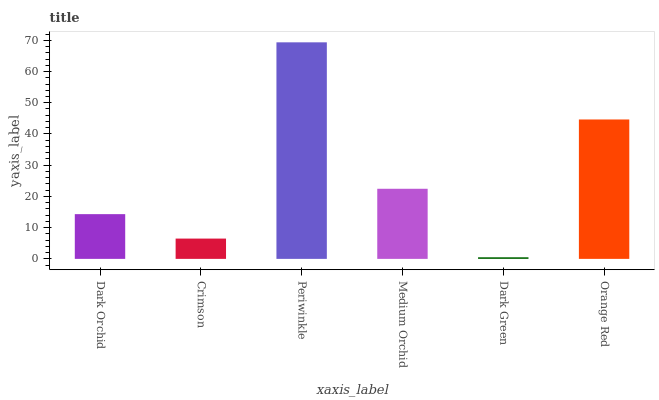Is Dark Green the minimum?
Answer yes or no. Yes. Is Periwinkle the maximum?
Answer yes or no. Yes. Is Crimson the minimum?
Answer yes or no. No. Is Crimson the maximum?
Answer yes or no. No. Is Dark Orchid greater than Crimson?
Answer yes or no. Yes. Is Crimson less than Dark Orchid?
Answer yes or no. Yes. Is Crimson greater than Dark Orchid?
Answer yes or no. No. Is Dark Orchid less than Crimson?
Answer yes or no. No. Is Medium Orchid the high median?
Answer yes or no. Yes. Is Dark Orchid the low median?
Answer yes or no. Yes. Is Orange Red the high median?
Answer yes or no. No. Is Dark Green the low median?
Answer yes or no. No. 